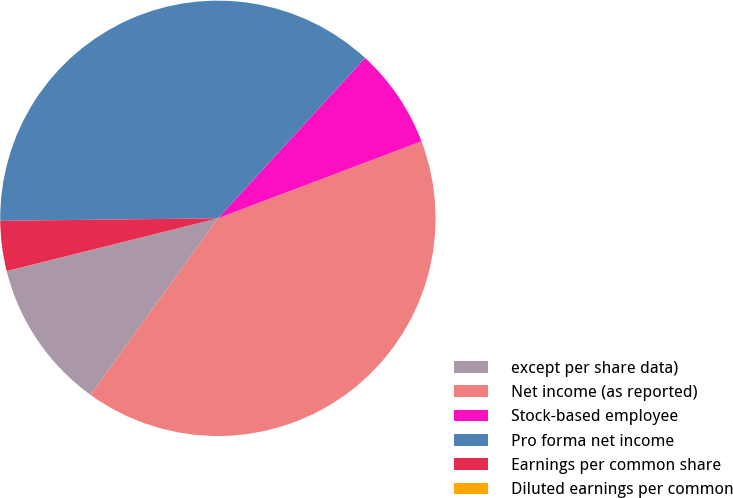Convert chart. <chart><loc_0><loc_0><loc_500><loc_500><pie_chart><fcel>except per share data)<fcel>Net income (as reported)<fcel>Stock-based employee<fcel>Pro forma net income<fcel>Earnings per common share<fcel>Diluted earnings per common<nl><fcel>11.14%<fcel>40.71%<fcel>7.43%<fcel>37.0%<fcel>3.72%<fcel>0.01%<nl></chart> 